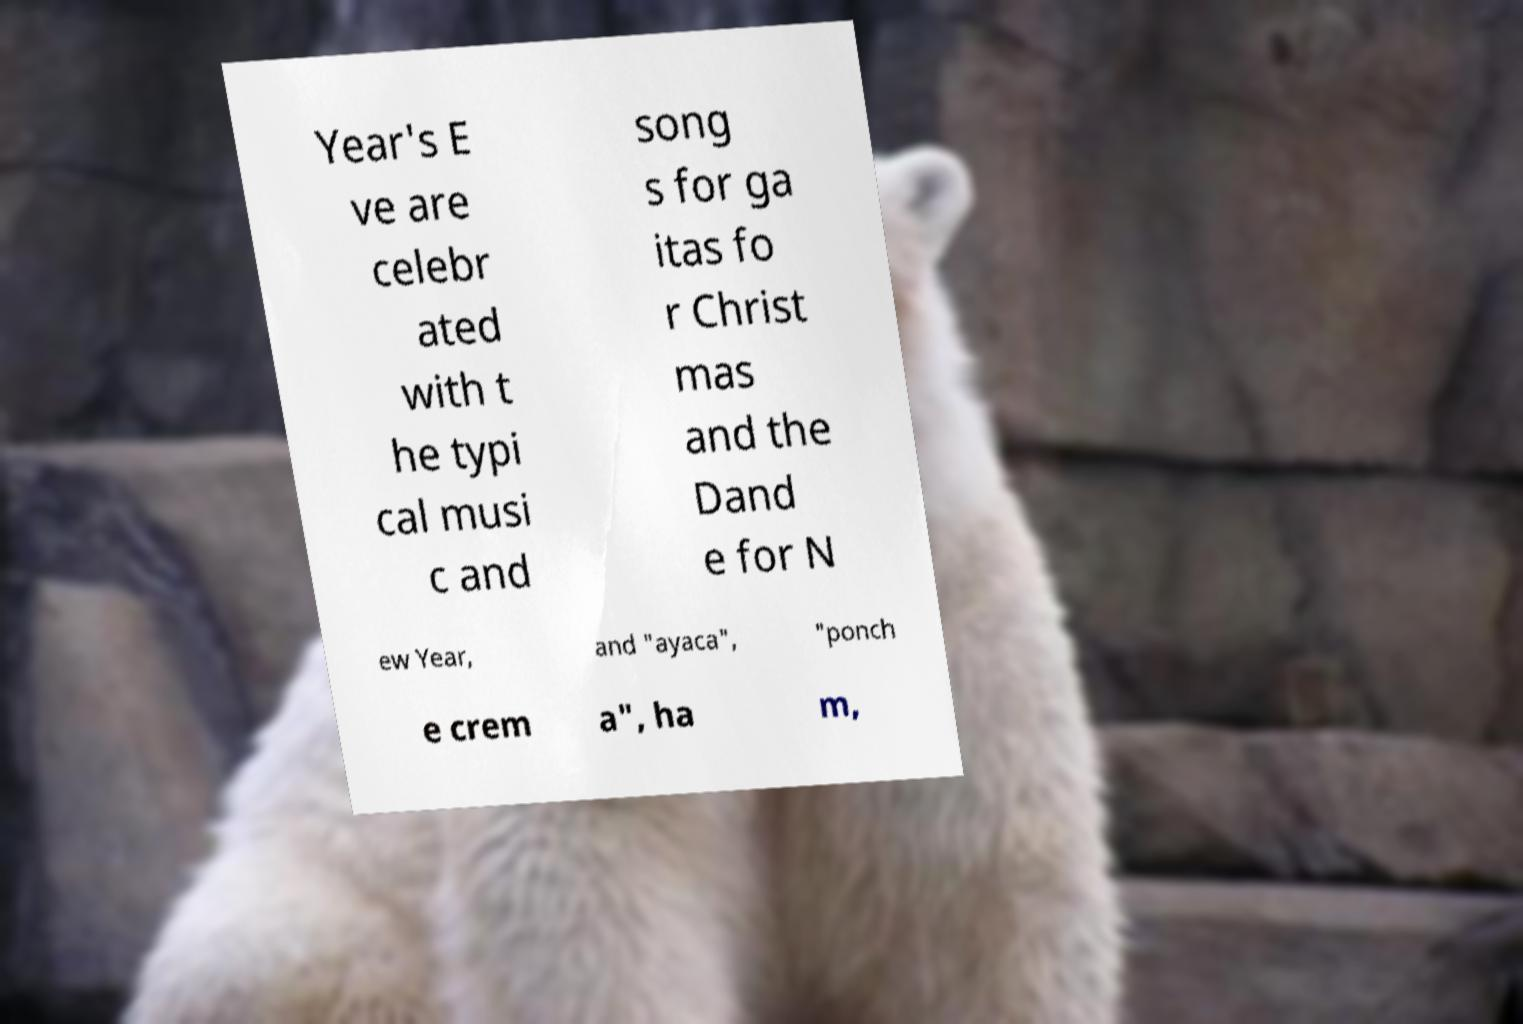What messages or text are displayed in this image? I need them in a readable, typed format. Year's E ve are celebr ated with t he typi cal musi c and song s for ga itas fo r Christ mas and the Dand e for N ew Year, and "ayaca", "ponch e crem a", ha m, 